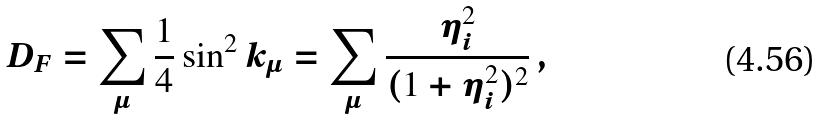<formula> <loc_0><loc_0><loc_500><loc_500>D _ { F } = \sum _ { \mu } \frac { 1 } { 4 } \sin ^ { 2 } k _ { \mu } = \sum _ { \mu } \frac { \eta _ { i } ^ { 2 } } { ( 1 + \eta _ { i } ^ { 2 } ) ^ { 2 } } \, ,</formula> 